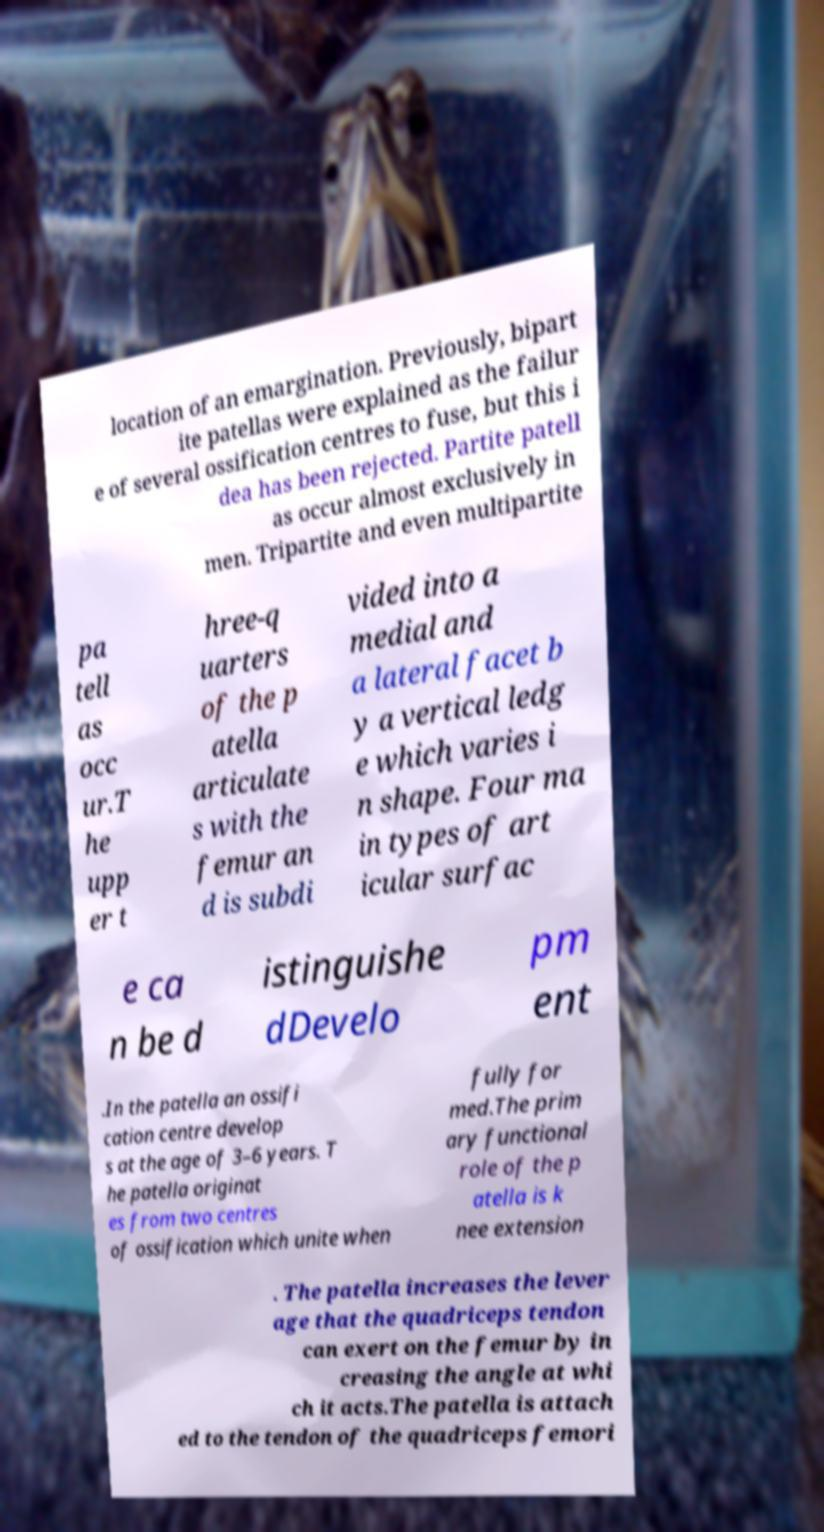Can you read and provide the text displayed in the image?This photo seems to have some interesting text. Can you extract and type it out for me? location of an emargination. Previously, bipart ite patellas were explained as the failur e of several ossification centres to fuse, but this i dea has been rejected. Partite patell as occur almost exclusively in men. Tripartite and even multipartite pa tell as occ ur.T he upp er t hree-q uarters of the p atella articulate s with the femur an d is subdi vided into a medial and a lateral facet b y a vertical ledg e which varies i n shape. Four ma in types of art icular surfac e ca n be d istinguishe dDevelo pm ent .In the patella an ossifi cation centre develop s at the age of 3–6 years. T he patella originat es from two centres of ossification which unite when fully for med.The prim ary functional role of the p atella is k nee extension . The patella increases the lever age that the quadriceps tendon can exert on the femur by in creasing the angle at whi ch it acts.The patella is attach ed to the tendon of the quadriceps femori 